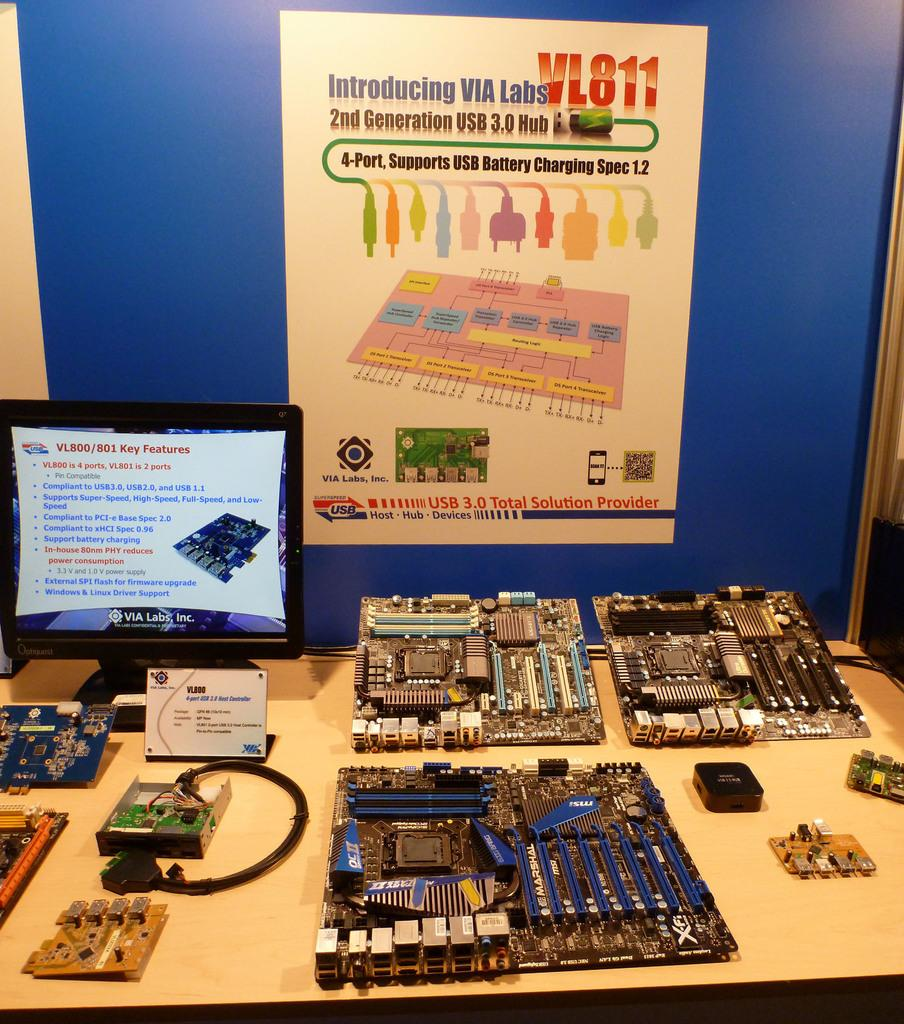<image>
Render a clear and concise summary of the photo. a table full of VIA Labs VL011 chips 